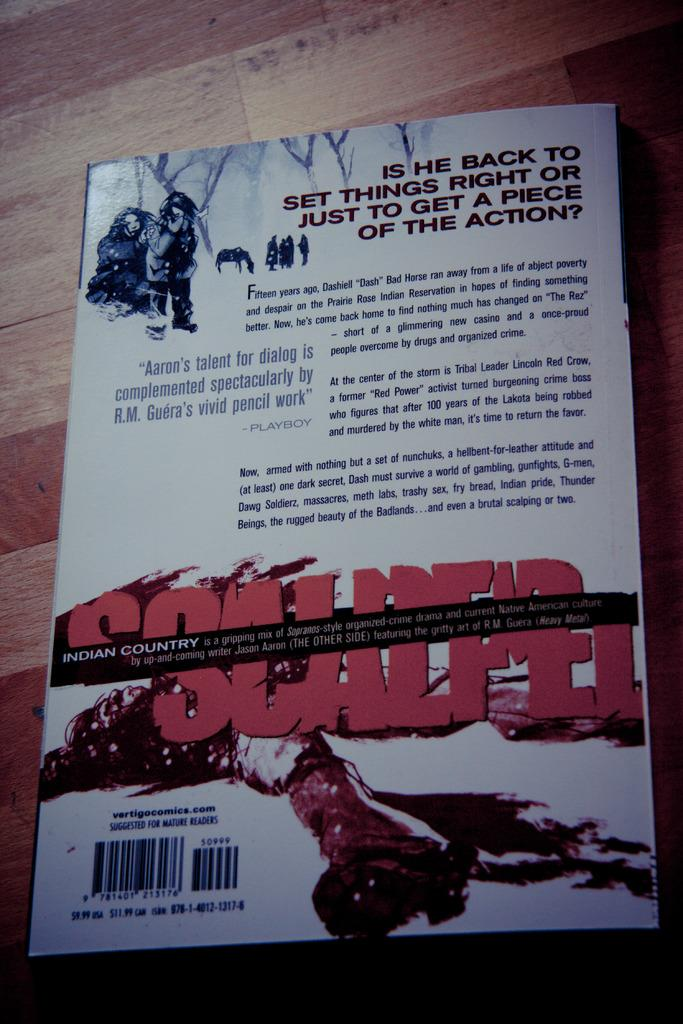Provide a one-sentence caption for the provided image. Book about the Indian country  who is all about  casino and crime. 